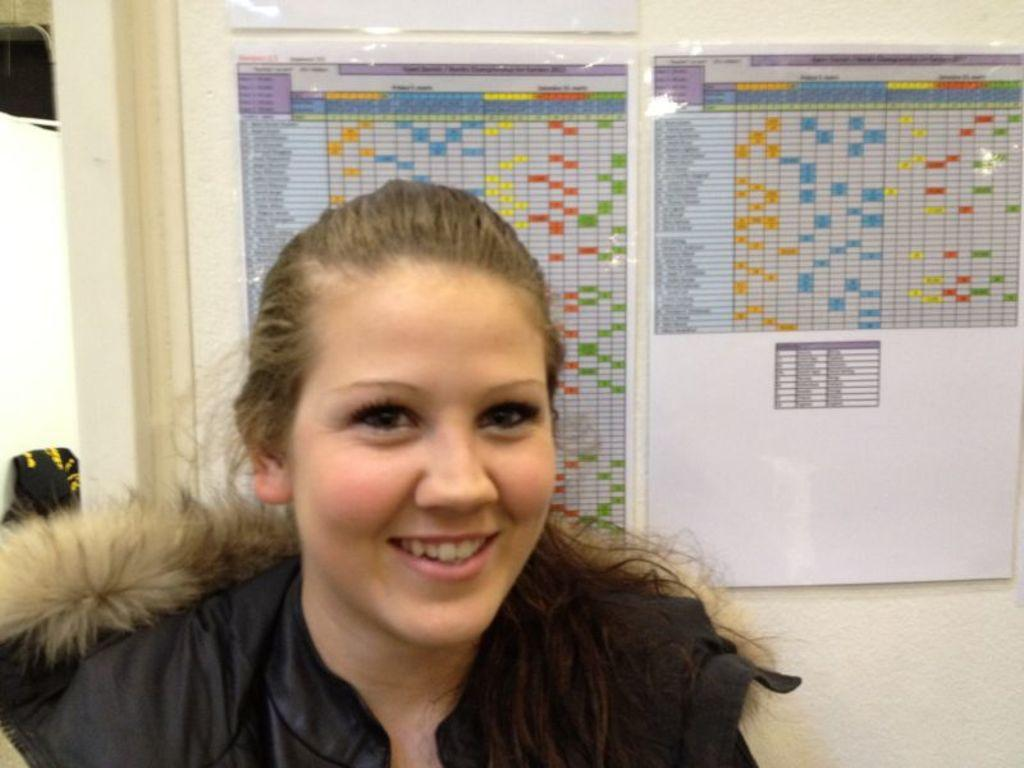Who is present in the image? There is a woman in the image. What can be seen on the wall in the background of the image? There are papers pasted on a wall in the background of the image. What type of produce is being stored in the coal bin in the image? There is no produce or coal bin present in the image. How many mice can be seen running around the woman's feet in the image? There are no mice present in the image. 